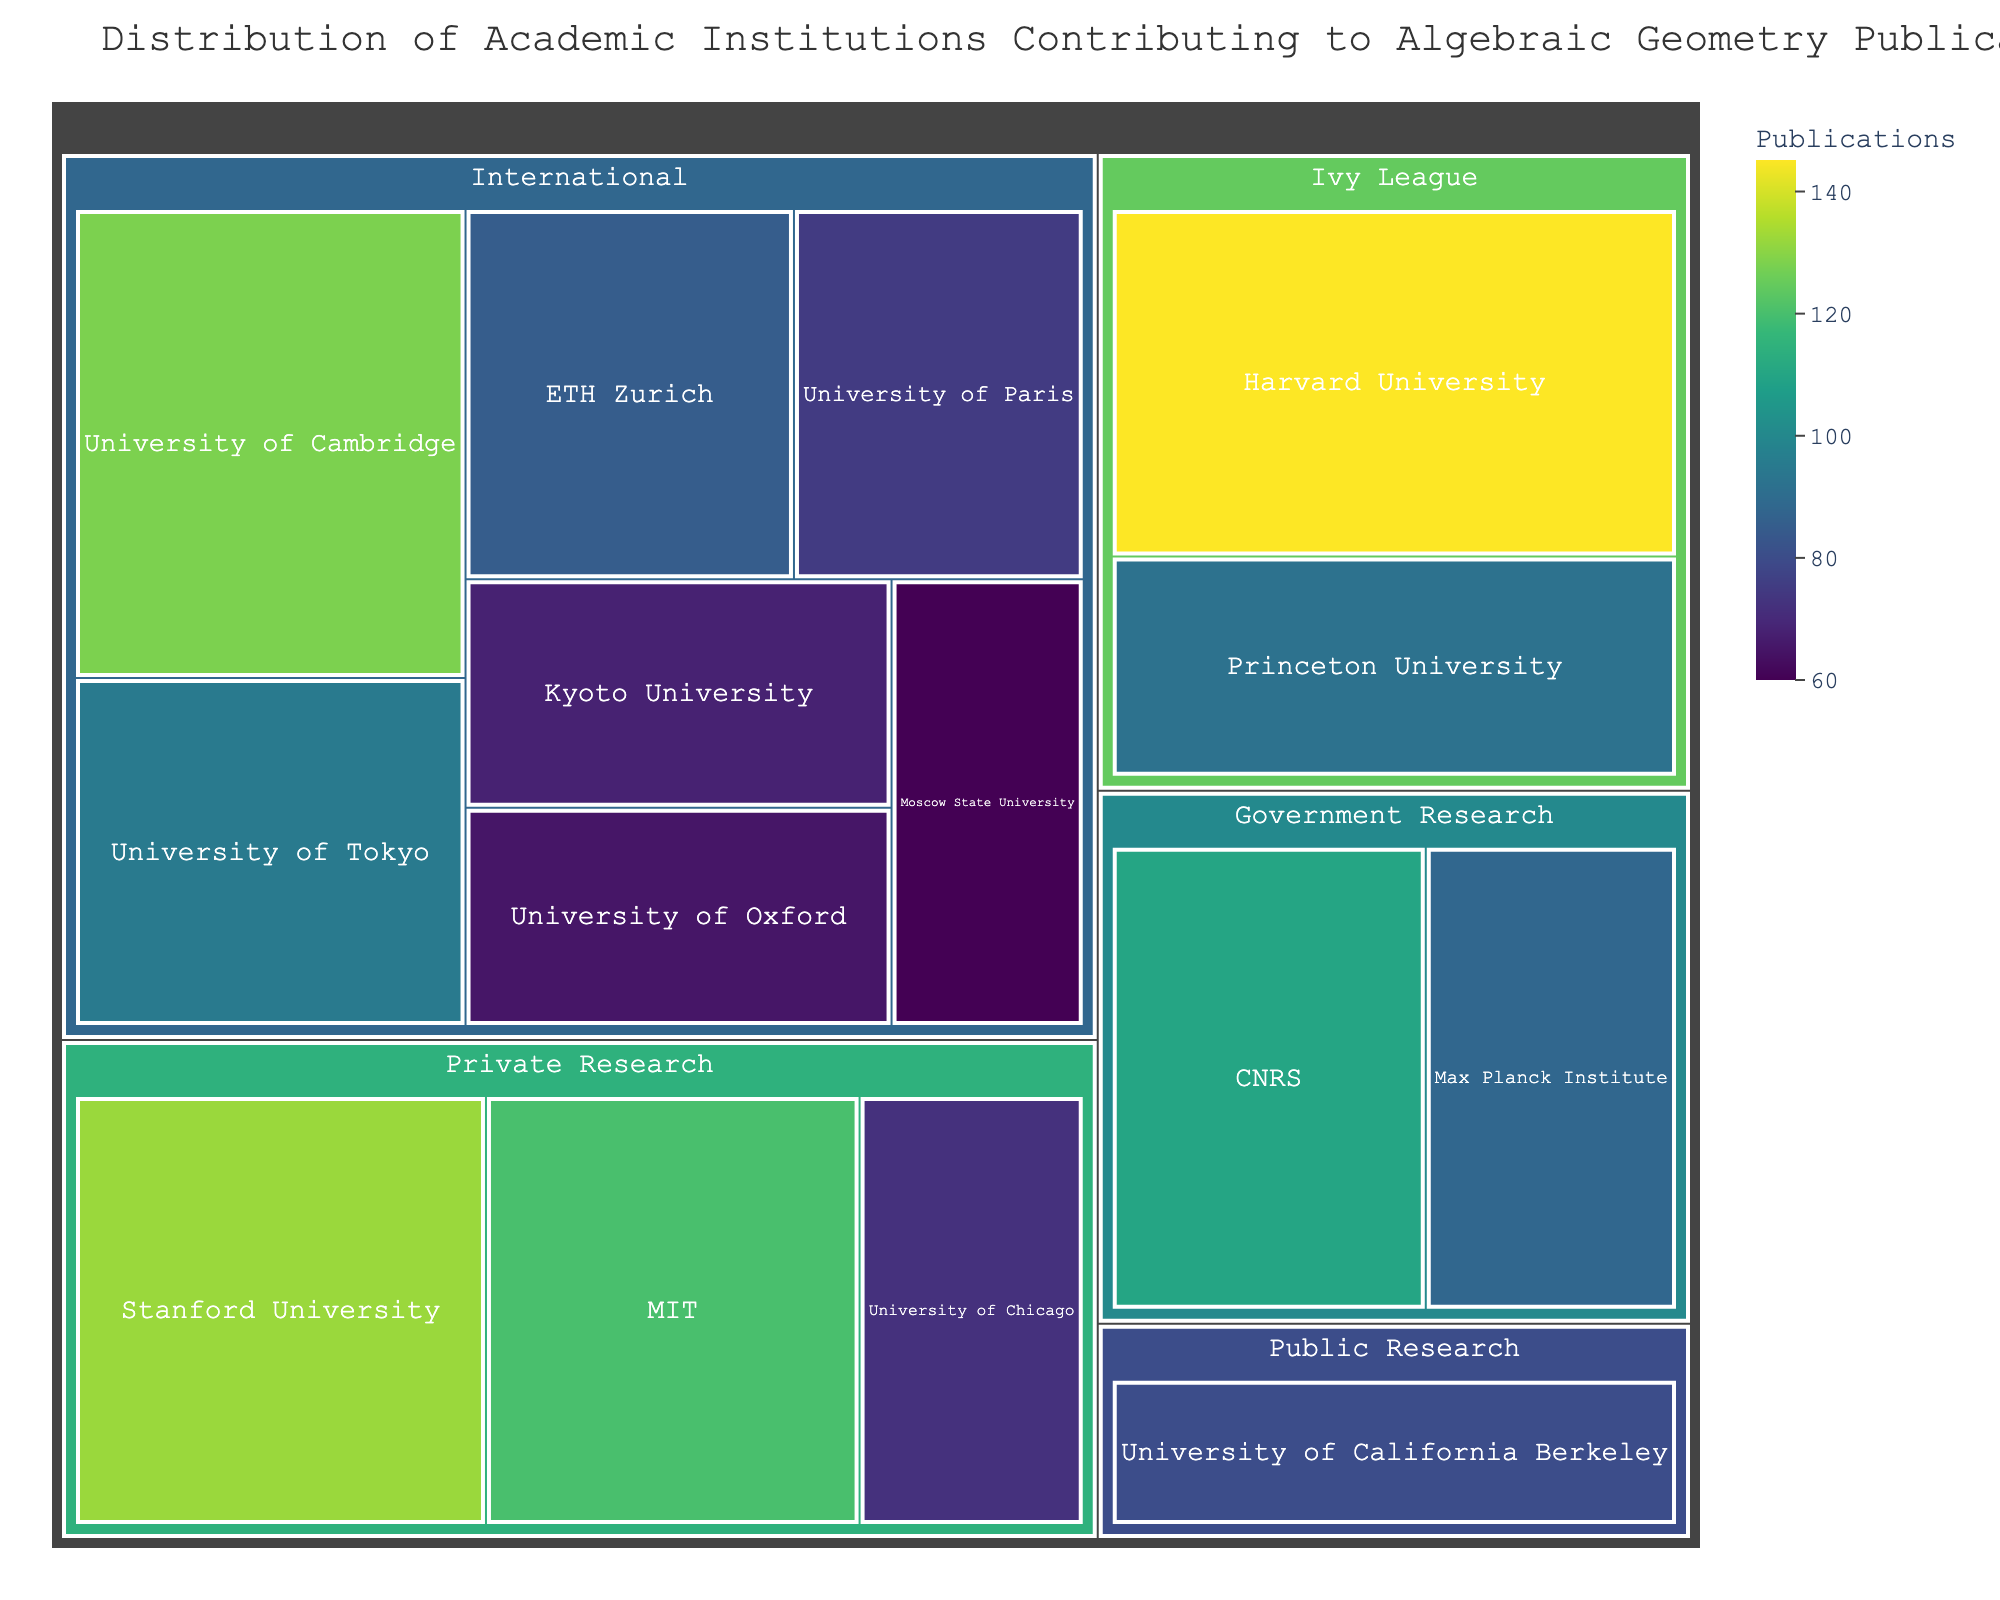How many publications are contributed by the Ivy League institutions? To determine the total number of publications from Ivy League institutions, add the number of publications from Harvard University and Princeton University. Harvard University has 145 publications and Princeton University has 92, so 145 + 92 = 237.
Answer: 237 Which category has the highest total number of publications? Sum the publications within each category: Ivy League (145 + 92 = 237), Private Research (132 + 120 + 72 = 324), International (128 + 95 + 85 + 75 + 68 + 65 + 60 = 576), Government Research (110 + 88 = 198), and Public Research (80). The International category has the highest total with 576 publications.
Answer: International Which institution has the fewest publications, and how many? Observing the treemap, look for the smallest segment to find the institution with the fewest publications. Moscow State University has the fewest publications with 60.
Answer: Moscow State University, 60 What is the difference in the number of publications between the University of Cambridge and the University of Tokyo? Find the number of publications for University of Cambridge (128) and University of Tokyo (95). Calculate the difference: 128 - 95 = 33.
Answer: 33 How many institutions have more than 100 publications? From the treemap, identify the institutions with more than 100 publications: Harvard University (145), Stanford University (132), University of Cambridge (128), MIT (120), and CNRS (110). There are 5 institutions in total.
Answer: 5 What is the range of publications among the institutions in the Private Research category? Find the maximum and minimum number of publications in the Private Research category: Stanford University (132) and University of Chicago (72). The range is the maximum minus the minimum, so 132 - 72 = 60.
Answer: 60 Compare the contributions from Ivy League and Government Research institutions. Which has more publications and by how much? Calculate the total from Ivy League (145 [Harvard] + 92 [Princeton] = 237) and Government Research (110 [CNRS] + 88 [Max Planck Institute] = 198). Ivy League has more, and the difference is 237 - 198 = 39.
Answer: Ivy League, 39 What percentage of the total publications are contributed by MIT? Sum the total publications from all institutions: 145 + 132 + 128 + 120 + 110 + 95 + 92 + 88 + 85 + 80 + 75 + 72 + 68 + 65 + 60 = 1415. MIT has 120 publications, so the percentage is (120 / 1415) * 100 ≈ 8.48%.
Answer: 8.48% Which institution in the International category has the highest number of publications? In the International category, compare the number of publications across institutions. University of Cambridge has the highest with 128 publications.
Answer: University of Cambridge 